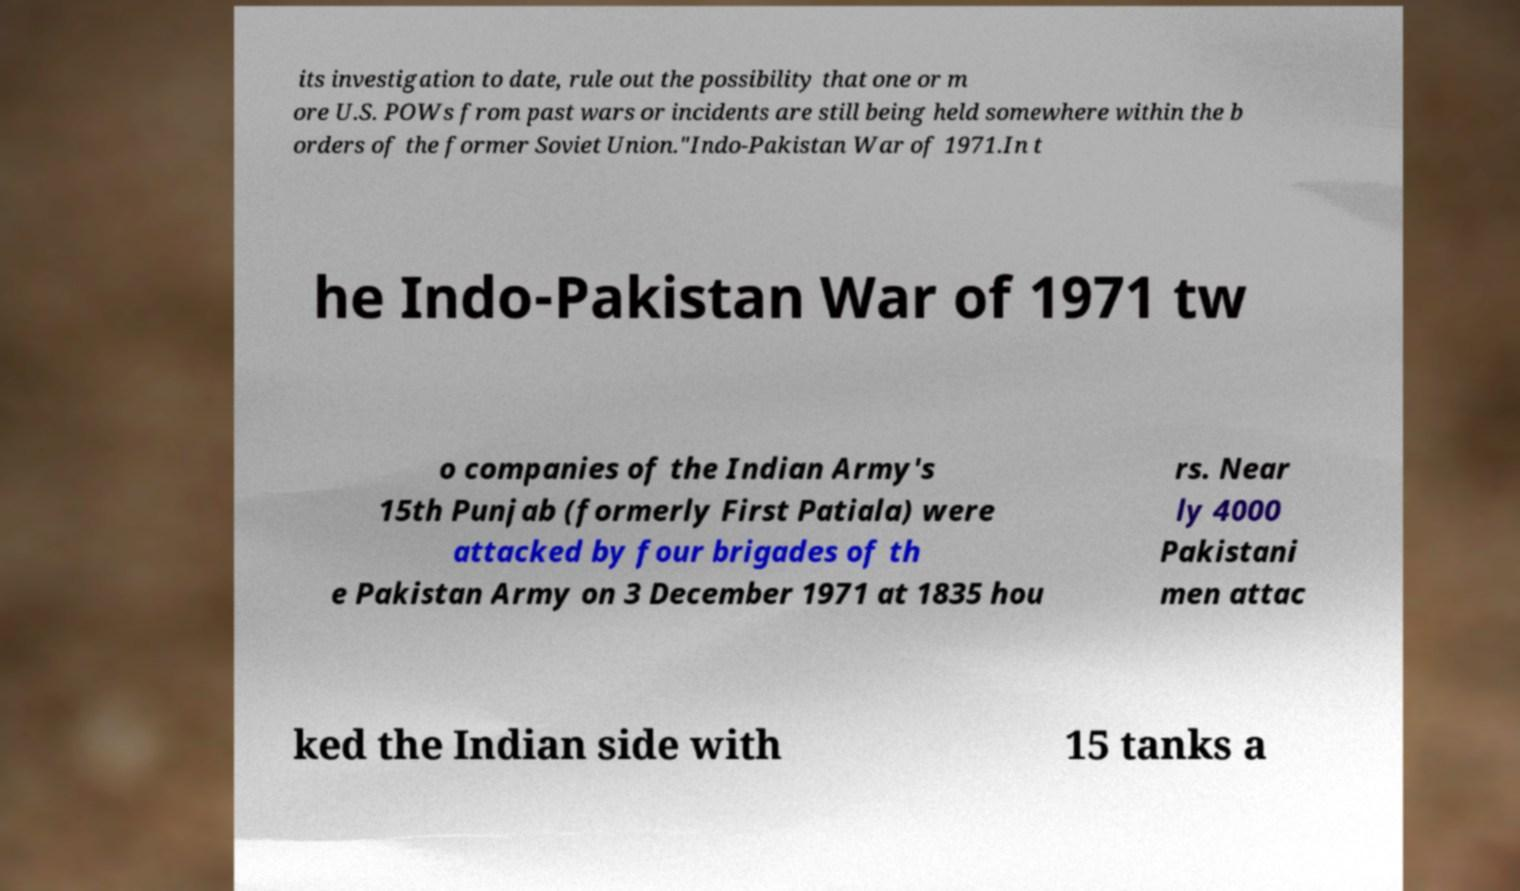Please identify and transcribe the text found in this image. its investigation to date, rule out the possibility that one or m ore U.S. POWs from past wars or incidents are still being held somewhere within the b orders of the former Soviet Union."Indo-Pakistan War of 1971.In t he Indo-Pakistan War of 1971 tw o companies of the Indian Army's 15th Punjab (formerly First Patiala) were attacked by four brigades of th e Pakistan Army on 3 December 1971 at 1835 hou rs. Near ly 4000 Pakistani men attac ked the Indian side with 15 tanks a 